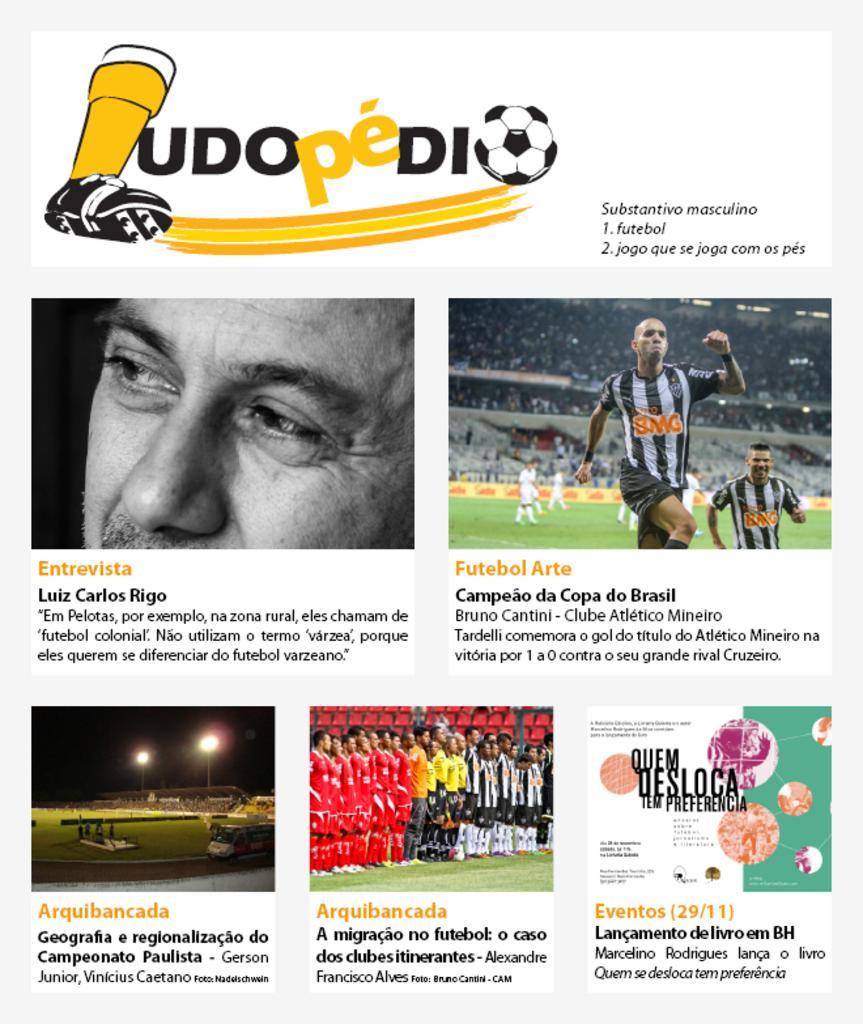How would you summarize this image in a sentence or two? This is an advertisement. In this image we can see some text, persons, auditorium, ground, lights, logos are there. 